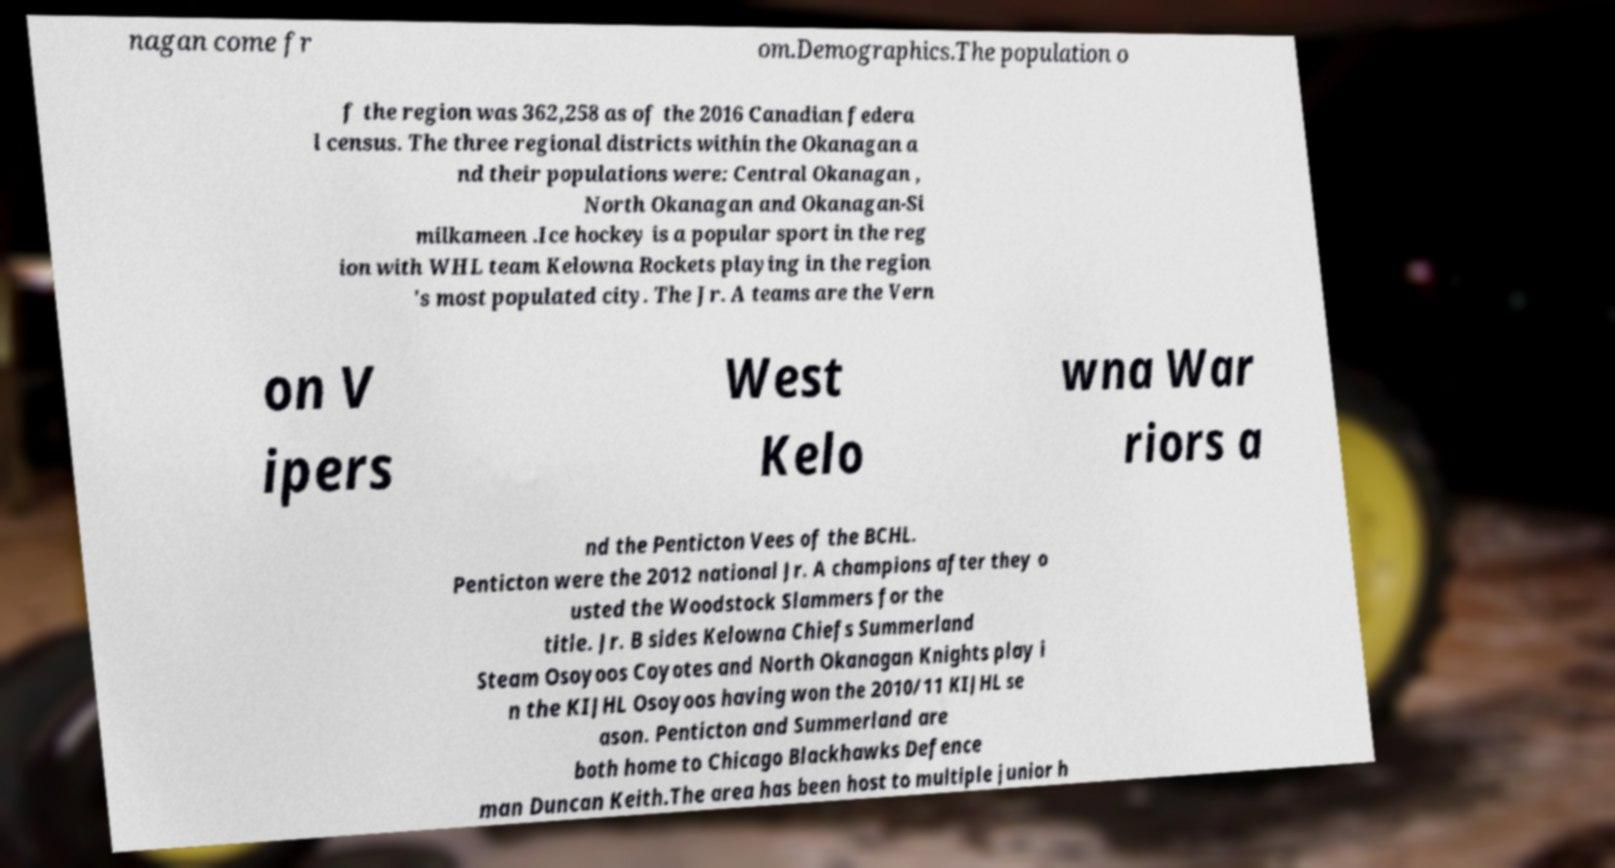There's text embedded in this image that I need extracted. Can you transcribe it verbatim? nagan come fr om.Demographics.The population o f the region was 362,258 as of the 2016 Canadian federa l census. The three regional districts within the Okanagan a nd their populations were: Central Okanagan , North Okanagan and Okanagan-Si milkameen .Ice hockey is a popular sport in the reg ion with WHL team Kelowna Rockets playing in the region 's most populated city. The Jr. A teams are the Vern on V ipers West Kelo wna War riors a nd the Penticton Vees of the BCHL. Penticton were the 2012 national Jr. A champions after they o usted the Woodstock Slammers for the title. Jr. B sides Kelowna Chiefs Summerland Steam Osoyoos Coyotes and North Okanagan Knights play i n the KIJHL Osoyoos having won the 2010/11 KIJHL se ason. Penticton and Summerland are both home to Chicago Blackhawks Defence man Duncan Keith.The area has been host to multiple junior h 